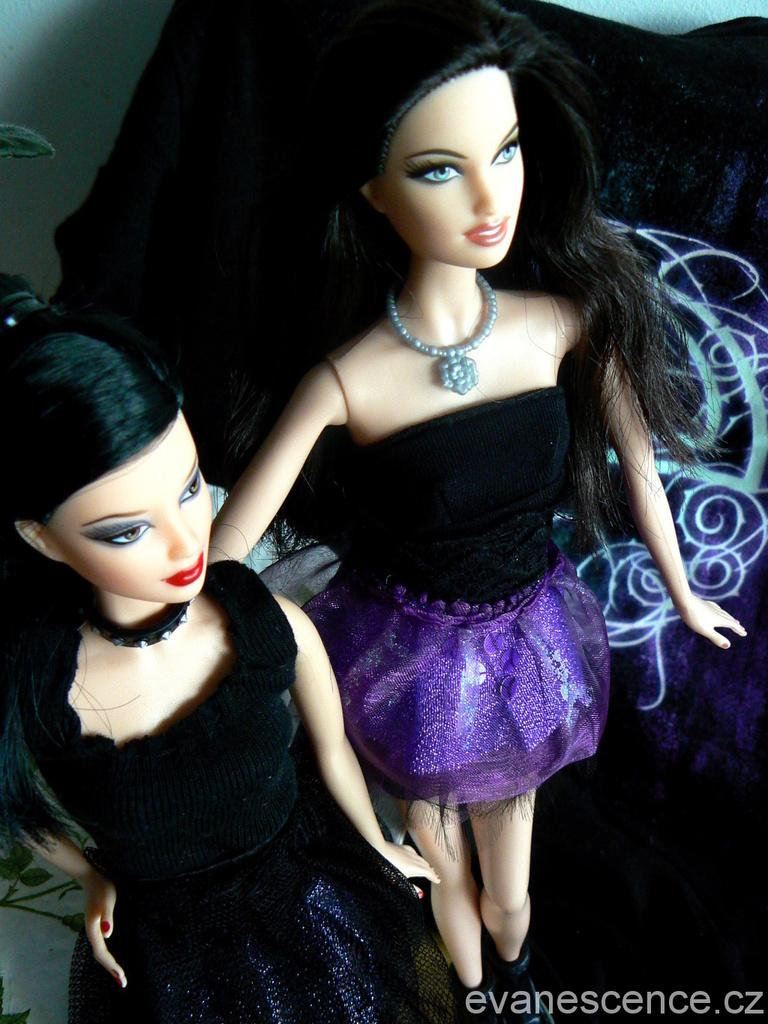How many dolls are present in the image? There are two dolls in the image. What can be seen in the background of the image? There is a cloth and a wall visible in the background of the image. Is there any additional information about the image's appearance? Yes, there is a watermark on the right side bottom of the image. What type of grain is being harvested by the hen in the image? There is no hen or grain present in the image; it features two dolls and a background with a cloth and a wall. 